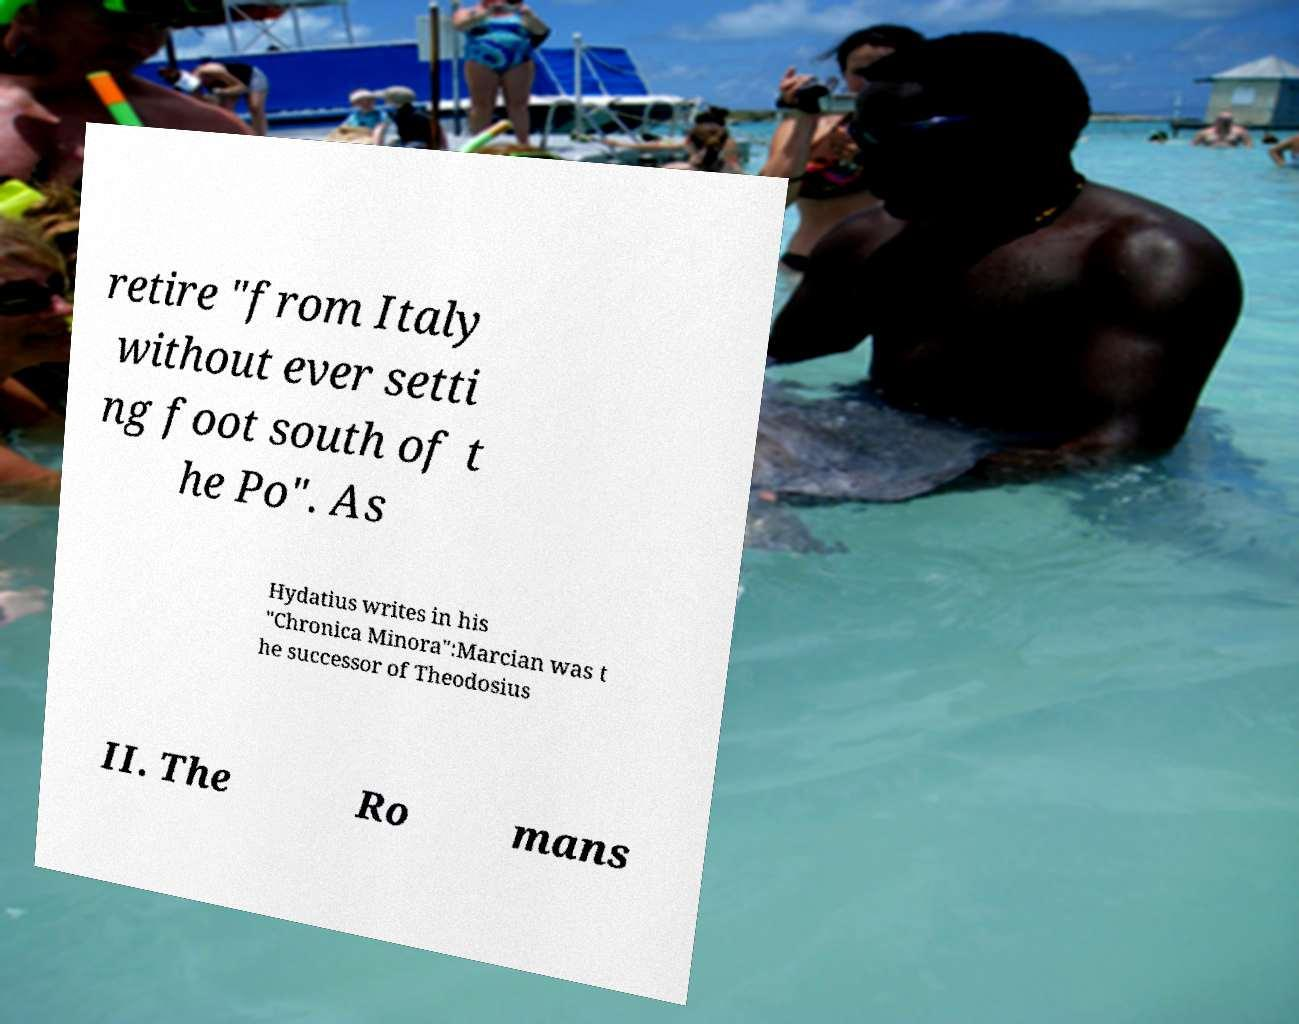There's text embedded in this image that I need extracted. Can you transcribe it verbatim? retire "from Italy without ever setti ng foot south of t he Po". As Hydatius writes in his "Chronica Minora":Marcian was t he successor of Theodosius II. The Ro mans 